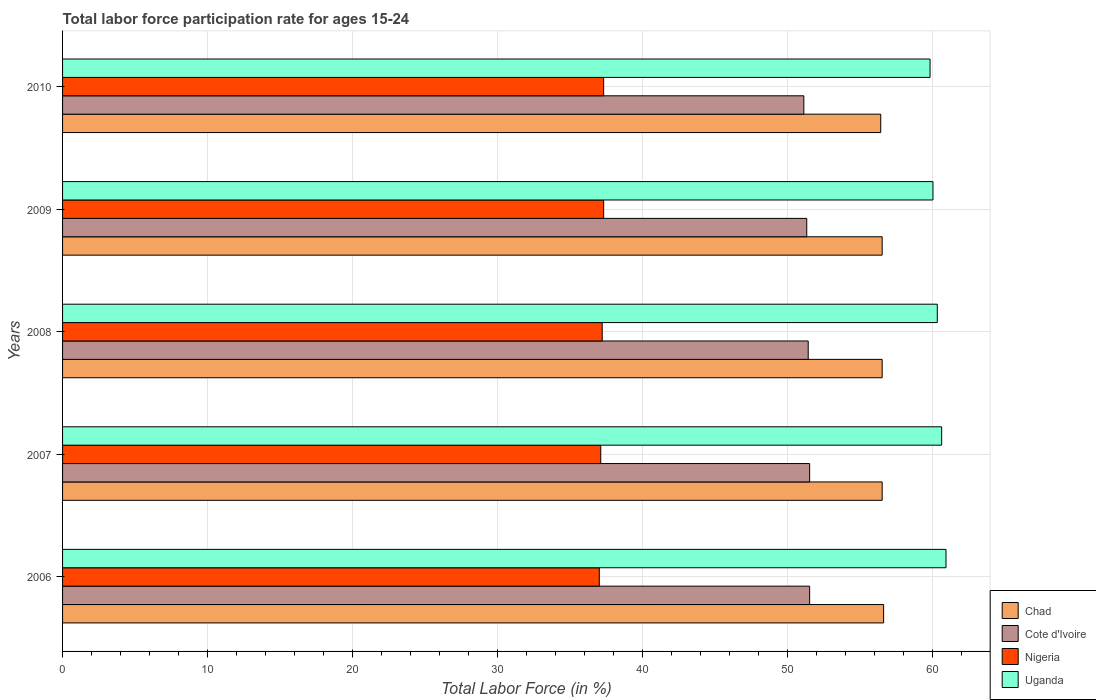How many groups of bars are there?
Offer a very short reply. 5. How many bars are there on the 1st tick from the top?
Offer a very short reply. 4. How many bars are there on the 2nd tick from the bottom?
Your answer should be compact. 4. What is the label of the 5th group of bars from the top?
Make the answer very short. 2006. What is the labor force participation rate in Chad in 2008?
Provide a succinct answer. 56.5. Across all years, what is the maximum labor force participation rate in Cote d'Ivoire?
Your answer should be compact. 51.5. What is the total labor force participation rate in Uganda in the graph?
Offer a terse response. 301.6. What is the difference between the labor force participation rate in Uganda in 2006 and that in 2007?
Your response must be concise. 0.3. What is the difference between the labor force participation rate in Cote d'Ivoire in 2010 and the labor force participation rate in Nigeria in 2008?
Give a very brief answer. 13.9. What is the average labor force participation rate in Cote d'Ivoire per year?
Offer a very short reply. 51.36. In the year 2010, what is the difference between the labor force participation rate in Cote d'Ivoire and labor force participation rate in Nigeria?
Offer a very short reply. 13.8. What is the ratio of the labor force participation rate in Chad in 2006 to that in 2007?
Offer a terse response. 1. What is the difference between the highest and the second highest labor force participation rate in Chad?
Provide a short and direct response. 0.1. What is the difference between the highest and the lowest labor force participation rate in Uganda?
Offer a very short reply. 1.1. In how many years, is the labor force participation rate in Cote d'Ivoire greater than the average labor force participation rate in Cote d'Ivoire taken over all years?
Make the answer very short. 3. Is the sum of the labor force participation rate in Uganda in 2008 and 2010 greater than the maximum labor force participation rate in Nigeria across all years?
Offer a very short reply. Yes. Is it the case that in every year, the sum of the labor force participation rate in Nigeria and labor force participation rate in Chad is greater than the sum of labor force participation rate in Cote d'Ivoire and labor force participation rate in Uganda?
Keep it short and to the point. Yes. What does the 3rd bar from the top in 2008 represents?
Your answer should be very brief. Cote d'Ivoire. What does the 4th bar from the bottom in 2008 represents?
Give a very brief answer. Uganda. Is it the case that in every year, the sum of the labor force participation rate in Cote d'Ivoire and labor force participation rate in Chad is greater than the labor force participation rate in Uganda?
Provide a succinct answer. Yes. Are the values on the major ticks of X-axis written in scientific E-notation?
Your answer should be very brief. No. Where does the legend appear in the graph?
Ensure brevity in your answer.  Bottom right. What is the title of the graph?
Give a very brief answer. Total labor force participation rate for ages 15-24. What is the label or title of the X-axis?
Make the answer very short. Total Labor Force (in %). What is the label or title of the Y-axis?
Make the answer very short. Years. What is the Total Labor Force (in %) of Chad in 2006?
Offer a very short reply. 56.6. What is the Total Labor Force (in %) in Cote d'Ivoire in 2006?
Your response must be concise. 51.5. What is the Total Labor Force (in %) in Uganda in 2006?
Your response must be concise. 60.9. What is the Total Labor Force (in %) in Chad in 2007?
Offer a very short reply. 56.5. What is the Total Labor Force (in %) of Cote d'Ivoire in 2007?
Make the answer very short. 51.5. What is the Total Labor Force (in %) in Nigeria in 2007?
Ensure brevity in your answer.  37.1. What is the Total Labor Force (in %) of Uganda in 2007?
Your answer should be very brief. 60.6. What is the Total Labor Force (in %) of Chad in 2008?
Offer a terse response. 56.5. What is the Total Labor Force (in %) of Cote d'Ivoire in 2008?
Your answer should be compact. 51.4. What is the Total Labor Force (in %) of Nigeria in 2008?
Keep it short and to the point. 37.2. What is the Total Labor Force (in %) in Uganda in 2008?
Ensure brevity in your answer.  60.3. What is the Total Labor Force (in %) of Chad in 2009?
Your response must be concise. 56.5. What is the Total Labor Force (in %) in Cote d'Ivoire in 2009?
Make the answer very short. 51.3. What is the Total Labor Force (in %) in Nigeria in 2009?
Give a very brief answer. 37.3. What is the Total Labor Force (in %) in Uganda in 2009?
Offer a terse response. 60. What is the Total Labor Force (in %) in Chad in 2010?
Offer a terse response. 56.4. What is the Total Labor Force (in %) in Cote d'Ivoire in 2010?
Your response must be concise. 51.1. What is the Total Labor Force (in %) in Nigeria in 2010?
Your answer should be very brief. 37.3. What is the Total Labor Force (in %) in Uganda in 2010?
Keep it short and to the point. 59.8. Across all years, what is the maximum Total Labor Force (in %) of Chad?
Your answer should be very brief. 56.6. Across all years, what is the maximum Total Labor Force (in %) of Cote d'Ivoire?
Keep it short and to the point. 51.5. Across all years, what is the maximum Total Labor Force (in %) of Nigeria?
Ensure brevity in your answer.  37.3. Across all years, what is the maximum Total Labor Force (in %) of Uganda?
Offer a very short reply. 60.9. Across all years, what is the minimum Total Labor Force (in %) of Chad?
Your answer should be compact. 56.4. Across all years, what is the minimum Total Labor Force (in %) in Cote d'Ivoire?
Offer a very short reply. 51.1. Across all years, what is the minimum Total Labor Force (in %) of Uganda?
Make the answer very short. 59.8. What is the total Total Labor Force (in %) of Chad in the graph?
Provide a succinct answer. 282.5. What is the total Total Labor Force (in %) in Cote d'Ivoire in the graph?
Provide a succinct answer. 256.8. What is the total Total Labor Force (in %) of Nigeria in the graph?
Make the answer very short. 185.9. What is the total Total Labor Force (in %) of Uganda in the graph?
Offer a terse response. 301.6. What is the difference between the Total Labor Force (in %) of Chad in 2006 and that in 2007?
Make the answer very short. 0.1. What is the difference between the Total Labor Force (in %) in Cote d'Ivoire in 2006 and that in 2007?
Offer a very short reply. 0. What is the difference between the Total Labor Force (in %) of Nigeria in 2006 and that in 2007?
Offer a terse response. -0.1. What is the difference between the Total Labor Force (in %) in Uganda in 2006 and that in 2007?
Provide a succinct answer. 0.3. What is the difference between the Total Labor Force (in %) of Chad in 2006 and that in 2008?
Ensure brevity in your answer.  0.1. What is the difference between the Total Labor Force (in %) of Chad in 2006 and that in 2009?
Your answer should be very brief. 0.1. What is the difference between the Total Labor Force (in %) of Nigeria in 2006 and that in 2009?
Give a very brief answer. -0.3. What is the difference between the Total Labor Force (in %) in Nigeria in 2006 and that in 2010?
Make the answer very short. -0.3. What is the difference between the Total Labor Force (in %) in Uganda in 2006 and that in 2010?
Offer a very short reply. 1.1. What is the difference between the Total Labor Force (in %) of Nigeria in 2007 and that in 2008?
Give a very brief answer. -0.1. What is the difference between the Total Labor Force (in %) in Chad in 2007 and that in 2009?
Keep it short and to the point. 0. What is the difference between the Total Labor Force (in %) of Uganda in 2007 and that in 2009?
Ensure brevity in your answer.  0.6. What is the difference between the Total Labor Force (in %) of Nigeria in 2007 and that in 2010?
Your response must be concise. -0.2. What is the difference between the Total Labor Force (in %) in Uganda in 2007 and that in 2010?
Provide a short and direct response. 0.8. What is the difference between the Total Labor Force (in %) in Cote d'Ivoire in 2008 and that in 2009?
Ensure brevity in your answer.  0.1. What is the difference between the Total Labor Force (in %) of Uganda in 2008 and that in 2009?
Offer a terse response. 0.3. What is the difference between the Total Labor Force (in %) in Chad in 2008 and that in 2010?
Keep it short and to the point. 0.1. What is the difference between the Total Labor Force (in %) in Cote d'Ivoire in 2008 and that in 2010?
Give a very brief answer. 0.3. What is the difference between the Total Labor Force (in %) in Uganda in 2008 and that in 2010?
Provide a succinct answer. 0.5. What is the difference between the Total Labor Force (in %) in Nigeria in 2009 and that in 2010?
Your answer should be compact. 0. What is the difference between the Total Labor Force (in %) of Uganda in 2009 and that in 2010?
Offer a terse response. 0.2. What is the difference between the Total Labor Force (in %) in Chad in 2006 and the Total Labor Force (in %) in Cote d'Ivoire in 2007?
Ensure brevity in your answer.  5.1. What is the difference between the Total Labor Force (in %) in Chad in 2006 and the Total Labor Force (in %) in Nigeria in 2007?
Keep it short and to the point. 19.5. What is the difference between the Total Labor Force (in %) in Chad in 2006 and the Total Labor Force (in %) in Uganda in 2007?
Offer a very short reply. -4. What is the difference between the Total Labor Force (in %) in Nigeria in 2006 and the Total Labor Force (in %) in Uganda in 2007?
Offer a terse response. -23.6. What is the difference between the Total Labor Force (in %) of Chad in 2006 and the Total Labor Force (in %) of Cote d'Ivoire in 2008?
Your response must be concise. 5.2. What is the difference between the Total Labor Force (in %) in Cote d'Ivoire in 2006 and the Total Labor Force (in %) in Uganda in 2008?
Give a very brief answer. -8.8. What is the difference between the Total Labor Force (in %) of Nigeria in 2006 and the Total Labor Force (in %) of Uganda in 2008?
Your answer should be compact. -23.3. What is the difference between the Total Labor Force (in %) of Chad in 2006 and the Total Labor Force (in %) of Cote d'Ivoire in 2009?
Offer a very short reply. 5.3. What is the difference between the Total Labor Force (in %) of Chad in 2006 and the Total Labor Force (in %) of Nigeria in 2009?
Ensure brevity in your answer.  19.3. What is the difference between the Total Labor Force (in %) of Cote d'Ivoire in 2006 and the Total Labor Force (in %) of Uganda in 2009?
Offer a very short reply. -8.5. What is the difference between the Total Labor Force (in %) in Nigeria in 2006 and the Total Labor Force (in %) in Uganda in 2009?
Offer a very short reply. -23. What is the difference between the Total Labor Force (in %) in Chad in 2006 and the Total Labor Force (in %) in Cote d'Ivoire in 2010?
Ensure brevity in your answer.  5.5. What is the difference between the Total Labor Force (in %) in Chad in 2006 and the Total Labor Force (in %) in Nigeria in 2010?
Make the answer very short. 19.3. What is the difference between the Total Labor Force (in %) of Nigeria in 2006 and the Total Labor Force (in %) of Uganda in 2010?
Keep it short and to the point. -22.8. What is the difference between the Total Labor Force (in %) of Chad in 2007 and the Total Labor Force (in %) of Cote d'Ivoire in 2008?
Ensure brevity in your answer.  5.1. What is the difference between the Total Labor Force (in %) of Chad in 2007 and the Total Labor Force (in %) of Nigeria in 2008?
Provide a short and direct response. 19.3. What is the difference between the Total Labor Force (in %) of Nigeria in 2007 and the Total Labor Force (in %) of Uganda in 2008?
Provide a succinct answer. -23.2. What is the difference between the Total Labor Force (in %) in Chad in 2007 and the Total Labor Force (in %) in Cote d'Ivoire in 2009?
Your answer should be compact. 5.2. What is the difference between the Total Labor Force (in %) in Chad in 2007 and the Total Labor Force (in %) in Nigeria in 2009?
Your answer should be very brief. 19.2. What is the difference between the Total Labor Force (in %) of Chad in 2007 and the Total Labor Force (in %) of Uganda in 2009?
Provide a short and direct response. -3.5. What is the difference between the Total Labor Force (in %) of Cote d'Ivoire in 2007 and the Total Labor Force (in %) of Nigeria in 2009?
Offer a terse response. 14.2. What is the difference between the Total Labor Force (in %) in Cote d'Ivoire in 2007 and the Total Labor Force (in %) in Uganda in 2009?
Keep it short and to the point. -8.5. What is the difference between the Total Labor Force (in %) of Nigeria in 2007 and the Total Labor Force (in %) of Uganda in 2009?
Your answer should be compact. -22.9. What is the difference between the Total Labor Force (in %) of Nigeria in 2007 and the Total Labor Force (in %) of Uganda in 2010?
Ensure brevity in your answer.  -22.7. What is the difference between the Total Labor Force (in %) in Chad in 2008 and the Total Labor Force (in %) in Cote d'Ivoire in 2009?
Keep it short and to the point. 5.2. What is the difference between the Total Labor Force (in %) of Chad in 2008 and the Total Labor Force (in %) of Uganda in 2009?
Provide a short and direct response. -3.5. What is the difference between the Total Labor Force (in %) of Cote d'Ivoire in 2008 and the Total Labor Force (in %) of Uganda in 2009?
Offer a very short reply. -8.6. What is the difference between the Total Labor Force (in %) in Nigeria in 2008 and the Total Labor Force (in %) in Uganda in 2009?
Your answer should be compact. -22.8. What is the difference between the Total Labor Force (in %) in Chad in 2008 and the Total Labor Force (in %) in Nigeria in 2010?
Your response must be concise. 19.2. What is the difference between the Total Labor Force (in %) in Nigeria in 2008 and the Total Labor Force (in %) in Uganda in 2010?
Make the answer very short. -22.6. What is the difference between the Total Labor Force (in %) of Chad in 2009 and the Total Labor Force (in %) of Nigeria in 2010?
Offer a terse response. 19.2. What is the difference between the Total Labor Force (in %) of Nigeria in 2009 and the Total Labor Force (in %) of Uganda in 2010?
Offer a very short reply. -22.5. What is the average Total Labor Force (in %) in Chad per year?
Provide a succinct answer. 56.5. What is the average Total Labor Force (in %) of Cote d'Ivoire per year?
Keep it short and to the point. 51.36. What is the average Total Labor Force (in %) of Nigeria per year?
Keep it short and to the point. 37.18. What is the average Total Labor Force (in %) of Uganda per year?
Provide a short and direct response. 60.32. In the year 2006, what is the difference between the Total Labor Force (in %) in Chad and Total Labor Force (in %) in Cote d'Ivoire?
Offer a very short reply. 5.1. In the year 2006, what is the difference between the Total Labor Force (in %) in Chad and Total Labor Force (in %) in Nigeria?
Keep it short and to the point. 19.6. In the year 2006, what is the difference between the Total Labor Force (in %) in Cote d'Ivoire and Total Labor Force (in %) in Nigeria?
Offer a very short reply. 14.5. In the year 2006, what is the difference between the Total Labor Force (in %) in Nigeria and Total Labor Force (in %) in Uganda?
Provide a short and direct response. -23.9. In the year 2007, what is the difference between the Total Labor Force (in %) in Chad and Total Labor Force (in %) in Nigeria?
Make the answer very short. 19.4. In the year 2007, what is the difference between the Total Labor Force (in %) of Chad and Total Labor Force (in %) of Uganda?
Your answer should be compact. -4.1. In the year 2007, what is the difference between the Total Labor Force (in %) of Cote d'Ivoire and Total Labor Force (in %) of Nigeria?
Your answer should be compact. 14.4. In the year 2007, what is the difference between the Total Labor Force (in %) in Nigeria and Total Labor Force (in %) in Uganda?
Offer a terse response. -23.5. In the year 2008, what is the difference between the Total Labor Force (in %) in Chad and Total Labor Force (in %) in Nigeria?
Make the answer very short. 19.3. In the year 2008, what is the difference between the Total Labor Force (in %) of Chad and Total Labor Force (in %) of Uganda?
Offer a terse response. -3.8. In the year 2008, what is the difference between the Total Labor Force (in %) of Cote d'Ivoire and Total Labor Force (in %) of Nigeria?
Keep it short and to the point. 14.2. In the year 2008, what is the difference between the Total Labor Force (in %) of Nigeria and Total Labor Force (in %) of Uganda?
Ensure brevity in your answer.  -23.1. In the year 2009, what is the difference between the Total Labor Force (in %) in Cote d'Ivoire and Total Labor Force (in %) in Nigeria?
Make the answer very short. 14. In the year 2009, what is the difference between the Total Labor Force (in %) of Cote d'Ivoire and Total Labor Force (in %) of Uganda?
Give a very brief answer. -8.7. In the year 2009, what is the difference between the Total Labor Force (in %) of Nigeria and Total Labor Force (in %) of Uganda?
Provide a succinct answer. -22.7. In the year 2010, what is the difference between the Total Labor Force (in %) in Chad and Total Labor Force (in %) in Cote d'Ivoire?
Provide a succinct answer. 5.3. In the year 2010, what is the difference between the Total Labor Force (in %) of Nigeria and Total Labor Force (in %) of Uganda?
Ensure brevity in your answer.  -22.5. What is the ratio of the Total Labor Force (in %) of Chad in 2006 to that in 2007?
Your answer should be very brief. 1. What is the ratio of the Total Labor Force (in %) in Cote d'Ivoire in 2006 to that in 2007?
Offer a very short reply. 1. What is the ratio of the Total Labor Force (in %) of Nigeria in 2006 to that in 2007?
Your answer should be compact. 1. What is the ratio of the Total Labor Force (in %) of Chad in 2006 to that in 2008?
Your answer should be very brief. 1. What is the ratio of the Total Labor Force (in %) in Uganda in 2006 to that in 2008?
Provide a succinct answer. 1.01. What is the ratio of the Total Labor Force (in %) in Cote d'Ivoire in 2006 to that in 2009?
Your response must be concise. 1. What is the ratio of the Total Labor Force (in %) in Nigeria in 2006 to that in 2009?
Your response must be concise. 0.99. What is the ratio of the Total Labor Force (in %) of Uganda in 2006 to that in 2009?
Make the answer very short. 1.01. What is the ratio of the Total Labor Force (in %) in Chad in 2006 to that in 2010?
Keep it short and to the point. 1. What is the ratio of the Total Labor Force (in %) in Cote d'Ivoire in 2006 to that in 2010?
Offer a very short reply. 1.01. What is the ratio of the Total Labor Force (in %) in Nigeria in 2006 to that in 2010?
Your answer should be very brief. 0.99. What is the ratio of the Total Labor Force (in %) of Uganda in 2006 to that in 2010?
Your answer should be compact. 1.02. What is the ratio of the Total Labor Force (in %) of Cote d'Ivoire in 2007 to that in 2008?
Provide a succinct answer. 1. What is the ratio of the Total Labor Force (in %) in Uganda in 2007 to that in 2008?
Provide a succinct answer. 1. What is the ratio of the Total Labor Force (in %) of Cote d'Ivoire in 2007 to that in 2009?
Provide a short and direct response. 1. What is the ratio of the Total Labor Force (in %) in Nigeria in 2007 to that in 2010?
Your response must be concise. 0.99. What is the ratio of the Total Labor Force (in %) of Uganda in 2007 to that in 2010?
Offer a terse response. 1.01. What is the ratio of the Total Labor Force (in %) of Chad in 2008 to that in 2009?
Offer a very short reply. 1. What is the ratio of the Total Labor Force (in %) in Cote d'Ivoire in 2008 to that in 2009?
Provide a succinct answer. 1. What is the ratio of the Total Labor Force (in %) of Uganda in 2008 to that in 2009?
Ensure brevity in your answer.  1. What is the ratio of the Total Labor Force (in %) of Cote d'Ivoire in 2008 to that in 2010?
Keep it short and to the point. 1.01. What is the ratio of the Total Labor Force (in %) of Nigeria in 2008 to that in 2010?
Your answer should be very brief. 1. What is the ratio of the Total Labor Force (in %) in Uganda in 2008 to that in 2010?
Provide a short and direct response. 1.01. What is the ratio of the Total Labor Force (in %) in Uganda in 2009 to that in 2010?
Your answer should be compact. 1. What is the difference between the highest and the lowest Total Labor Force (in %) of Chad?
Give a very brief answer. 0.2. What is the difference between the highest and the lowest Total Labor Force (in %) of Uganda?
Make the answer very short. 1.1. 